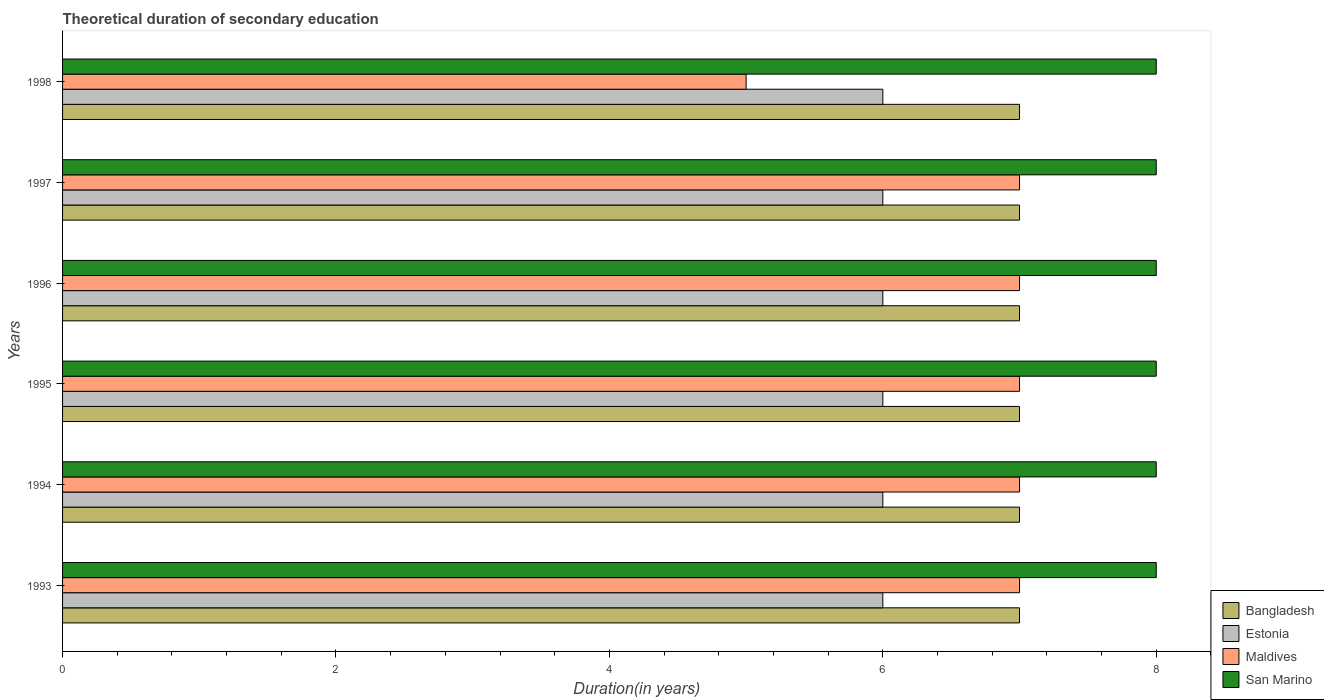Are the number of bars per tick equal to the number of legend labels?
Offer a terse response. Yes. Are the number of bars on each tick of the Y-axis equal?
Your answer should be compact. Yes. How many bars are there on the 6th tick from the top?
Your answer should be compact. 4. How many bars are there on the 2nd tick from the bottom?
Keep it short and to the point. 4. In how many cases, is the number of bars for a given year not equal to the number of legend labels?
Your answer should be compact. 0. What is the total theoretical duration of secondary education in Estonia in 1998?
Provide a short and direct response. 6. Across all years, what is the minimum total theoretical duration of secondary education in Maldives?
Offer a very short reply. 5. In which year was the total theoretical duration of secondary education in Maldives minimum?
Give a very brief answer. 1998. What is the total total theoretical duration of secondary education in Bangladesh in the graph?
Your response must be concise. 42. What is the difference between the total theoretical duration of secondary education in Maldives in 1994 and the total theoretical duration of secondary education in San Marino in 1996?
Ensure brevity in your answer.  -1. What is the average total theoretical duration of secondary education in Bangladesh per year?
Make the answer very short. 7. In the year 1995, what is the difference between the total theoretical duration of secondary education in Maldives and total theoretical duration of secondary education in San Marino?
Provide a short and direct response. -1. In how many years, is the total theoretical duration of secondary education in Maldives greater than 4.8 years?
Offer a very short reply. 6. What is the ratio of the total theoretical duration of secondary education in San Marino in 1993 to that in 1998?
Your answer should be compact. 1. Is the total theoretical duration of secondary education in Bangladesh in 1996 less than that in 1998?
Keep it short and to the point. No. What is the difference between the highest and the second highest total theoretical duration of secondary education in Maldives?
Your answer should be very brief. 0. What is the difference between the highest and the lowest total theoretical duration of secondary education in San Marino?
Offer a very short reply. 0. Is the sum of the total theoretical duration of secondary education in Maldives in 1995 and 1996 greater than the maximum total theoretical duration of secondary education in Bangladesh across all years?
Your answer should be very brief. Yes. What does the 4th bar from the top in 1998 represents?
Make the answer very short. Bangladesh. What does the 4th bar from the bottom in 1997 represents?
Your answer should be very brief. San Marino. Is it the case that in every year, the sum of the total theoretical duration of secondary education in Maldives and total theoretical duration of secondary education in San Marino is greater than the total theoretical duration of secondary education in Estonia?
Provide a short and direct response. Yes. How many years are there in the graph?
Provide a succinct answer. 6. What is the difference between two consecutive major ticks on the X-axis?
Your answer should be very brief. 2. Does the graph contain any zero values?
Offer a very short reply. No. Does the graph contain grids?
Your response must be concise. No. How many legend labels are there?
Offer a terse response. 4. What is the title of the graph?
Offer a very short reply. Theoretical duration of secondary education. Does "Indonesia" appear as one of the legend labels in the graph?
Make the answer very short. No. What is the label or title of the X-axis?
Make the answer very short. Duration(in years). What is the Duration(in years) in Bangladesh in 1993?
Ensure brevity in your answer.  7. What is the Duration(in years) of San Marino in 1993?
Provide a succinct answer. 8. What is the Duration(in years) in San Marino in 1994?
Provide a short and direct response. 8. What is the Duration(in years) in Estonia in 1995?
Your response must be concise. 6. What is the Duration(in years) of Maldives in 1995?
Provide a short and direct response. 7. What is the Duration(in years) of San Marino in 1995?
Provide a short and direct response. 8. What is the Duration(in years) of Bangladesh in 1996?
Keep it short and to the point. 7. What is the Duration(in years) of Maldives in 1996?
Your response must be concise. 7. What is the Duration(in years) of Bangladesh in 1997?
Keep it short and to the point. 7. What is the Duration(in years) of Maldives in 1997?
Ensure brevity in your answer.  7. What is the Duration(in years) of San Marino in 1997?
Provide a succinct answer. 8. What is the Duration(in years) in Maldives in 1998?
Offer a very short reply. 5. Across all years, what is the maximum Duration(in years) of Bangladesh?
Provide a short and direct response. 7. Across all years, what is the maximum Duration(in years) of Estonia?
Provide a succinct answer. 6. Across all years, what is the maximum Duration(in years) of San Marino?
Your answer should be compact. 8. Across all years, what is the minimum Duration(in years) in Estonia?
Ensure brevity in your answer.  6. Across all years, what is the minimum Duration(in years) of San Marino?
Keep it short and to the point. 8. What is the total Duration(in years) of San Marino in the graph?
Your response must be concise. 48. What is the difference between the Duration(in years) of Maldives in 1993 and that in 1994?
Ensure brevity in your answer.  0. What is the difference between the Duration(in years) of Estonia in 1993 and that in 1995?
Provide a short and direct response. 0. What is the difference between the Duration(in years) of San Marino in 1993 and that in 1995?
Offer a terse response. 0. What is the difference between the Duration(in years) in Bangladesh in 1993 and that in 1996?
Provide a succinct answer. 0. What is the difference between the Duration(in years) of Estonia in 1993 and that in 1996?
Keep it short and to the point. 0. What is the difference between the Duration(in years) of Maldives in 1993 and that in 1996?
Your answer should be very brief. 0. What is the difference between the Duration(in years) of Bangladesh in 1993 and that in 1997?
Your response must be concise. 0. What is the difference between the Duration(in years) in Maldives in 1993 and that in 1997?
Keep it short and to the point. 0. What is the difference between the Duration(in years) in Bangladesh in 1993 and that in 1998?
Provide a succinct answer. 0. What is the difference between the Duration(in years) of Estonia in 1993 and that in 1998?
Your answer should be compact. 0. What is the difference between the Duration(in years) in San Marino in 1993 and that in 1998?
Make the answer very short. 0. What is the difference between the Duration(in years) of Bangladesh in 1994 and that in 1996?
Give a very brief answer. 0. What is the difference between the Duration(in years) in San Marino in 1994 and that in 1996?
Your response must be concise. 0. What is the difference between the Duration(in years) of Bangladesh in 1994 and that in 1997?
Make the answer very short. 0. What is the difference between the Duration(in years) in Estonia in 1994 and that in 1997?
Your answer should be compact. 0. What is the difference between the Duration(in years) in Estonia in 1994 and that in 1998?
Keep it short and to the point. 0. What is the difference between the Duration(in years) of Maldives in 1994 and that in 1998?
Offer a very short reply. 2. What is the difference between the Duration(in years) of Bangladesh in 1995 and that in 1996?
Keep it short and to the point. 0. What is the difference between the Duration(in years) of Maldives in 1995 and that in 1996?
Your answer should be compact. 0. What is the difference between the Duration(in years) in Estonia in 1995 and that in 1997?
Provide a succinct answer. 0. What is the difference between the Duration(in years) in Maldives in 1995 and that in 1997?
Your answer should be very brief. 0. What is the difference between the Duration(in years) of Bangladesh in 1996 and that in 1997?
Ensure brevity in your answer.  0. What is the difference between the Duration(in years) in Estonia in 1996 and that in 1997?
Provide a short and direct response. 0. What is the difference between the Duration(in years) of San Marino in 1996 and that in 1998?
Provide a short and direct response. 0. What is the difference between the Duration(in years) in Bangladesh in 1997 and that in 1998?
Make the answer very short. 0. What is the difference between the Duration(in years) of Estonia in 1997 and that in 1998?
Provide a succinct answer. 0. What is the difference between the Duration(in years) of Maldives in 1997 and that in 1998?
Offer a very short reply. 2. What is the difference between the Duration(in years) in Bangladesh in 1993 and the Duration(in years) in Estonia in 1994?
Ensure brevity in your answer.  1. What is the difference between the Duration(in years) of Bangladesh in 1993 and the Duration(in years) of Maldives in 1994?
Offer a very short reply. 0. What is the difference between the Duration(in years) in Estonia in 1993 and the Duration(in years) in Maldives in 1994?
Give a very brief answer. -1. What is the difference between the Duration(in years) of Estonia in 1993 and the Duration(in years) of San Marino in 1994?
Keep it short and to the point. -2. What is the difference between the Duration(in years) in Estonia in 1993 and the Duration(in years) in Maldives in 1995?
Ensure brevity in your answer.  -1. What is the difference between the Duration(in years) in Bangladesh in 1993 and the Duration(in years) in Estonia in 1996?
Provide a succinct answer. 1. What is the difference between the Duration(in years) of Estonia in 1993 and the Duration(in years) of Maldives in 1996?
Provide a succinct answer. -1. What is the difference between the Duration(in years) of Estonia in 1993 and the Duration(in years) of San Marino in 1996?
Offer a terse response. -2. What is the difference between the Duration(in years) of Bangladesh in 1993 and the Duration(in years) of Estonia in 1997?
Provide a succinct answer. 1. What is the difference between the Duration(in years) in Estonia in 1993 and the Duration(in years) in San Marino in 1997?
Provide a short and direct response. -2. What is the difference between the Duration(in years) of Bangladesh in 1993 and the Duration(in years) of Maldives in 1998?
Your response must be concise. 2. What is the difference between the Duration(in years) in Bangladesh in 1993 and the Duration(in years) in San Marino in 1998?
Offer a very short reply. -1. What is the difference between the Duration(in years) of Maldives in 1993 and the Duration(in years) of San Marino in 1998?
Offer a terse response. -1. What is the difference between the Duration(in years) in Bangladesh in 1994 and the Duration(in years) in Estonia in 1995?
Offer a terse response. 1. What is the difference between the Duration(in years) of Bangladesh in 1994 and the Duration(in years) of Maldives in 1995?
Make the answer very short. 0. What is the difference between the Duration(in years) of Bangladesh in 1994 and the Duration(in years) of San Marino in 1995?
Give a very brief answer. -1. What is the difference between the Duration(in years) in Estonia in 1994 and the Duration(in years) in Maldives in 1995?
Ensure brevity in your answer.  -1. What is the difference between the Duration(in years) in Estonia in 1994 and the Duration(in years) in San Marino in 1995?
Give a very brief answer. -2. What is the difference between the Duration(in years) of Maldives in 1994 and the Duration(in years) of San Marino in 1995?
Your answer should be very brief. -1. What is the difference between the Duration(in years) in Bangladesh in 1994 and the Duration(in years) in San Marino in 1996?
Give a very brief answer. -1. What is the difference between the Duration(in years) of Estonia in 1994 and the Duration(in years) of San Marino in 1996?
Your answer should be compact. -2. What is the difference between the Duration(in years) in Maldives in 1994 and the Duration(in years) in San Marino in 1996?
Offer a terse response. -1. What is the difference between the Duration(in years) of Bangladesh in 1994 and the Duration(in years) of Maldives in 1997?
Provide a short and direct response. 0. What is the difference between the Duration(in years) in Bangladesh in 1994 and the Duration(in years) in San Marino in 1997?
Keep it short and to the point. -1. What is the difference between the Duration(in years) in Estonia in 1994 and the Duration(in years) in Maldives in 1997?
Make the answer very short. -1. What is the difference between the Duration(in years) in Bangladesh in 1994 and the Duration(in years) in Estonia in 1998?
Keep it short and to the point. 1. What is the difference between the Duration(in years) in Estonia in 1994 and the Duration(in years) in San Marino in 1998?
Your response must be concise. -2. What is the difference between the Duration(in years) in Maldives in 1994 and the Duration(in years) in San Marino in 1998?
Provide a short and direct response. -1. What is the difference between the Duration(in years) of Bangladesh in 1995 and the Duration(in years) of Estonia in 1996?
Keep it short and to the point. 1. What is the difference between the Duration(in years) of Bangladesh in 1995 and the Duration(in years) of Maldives in 1996?
Make the answer very short. 0. What is the difference between the Duration(in years) of Estonia in 1995 and the Duration(in years) of Maldives in 1996?
Make the answer very short. -1. What is the difference between the Duration(in years) in Bangladesh in 1995 and the Duration(in years) in Maldives in 1997?
Your response must be concise. 0. What is the difference between the Duration(in years) in Estonia in 1995 and the Duration(in years) in Maldives in 1997?
Provide a short and direct response. -1. What is the difference between the Duration(in years) of Bangladesh in 1995 and the Duration(in years) of Estonia in 1998?
Ensure brevity in your answer.  1. What is the difference between the Duration(in years) in Bangladesh in 1995 and the Duration(in years) in Maldives in 1998?
Provide a succinct answer. 2. What is the difference between the Duration(in years) of Bangladesh in 1995 and the Duration(in years) of San Marino in 1998?
Make the answer very short. -1. What is the difference between the Duration(in years) of Estonia in 1995 and the Duration(in years) of Maldives in 1998?
Make the answer very short. 1. What is the difference between the Duration(in years) of Estonia in 1995 and the Duration(in years) of San Marino in 1998?
Ensure brevity in your answer.  -2. What is the difference between the Duration(in years) in Maldives in 1995 and the Duration(in years) in San Marino in 1998?
Give a very brief answer. -1. What is the difference between the Duration(in years) of Bangladesh in 1996 and the Duration(in years) of Maldives in 1997?
Provide a short and direct response. 0. What is the difference between the Duration(in years) in Bangladesh in 1996 and the Duration(in years) in San Marino in 1997?
Ensure brevity in your answer.  -1. What is the difference between the Duration(in years) in Estonia in 1996 and the Duration(in years) in San Marino in 1997?
Ensure brevity in your answer.  -2. What is the difference between the Duration(in years) of Maldives in 1996 and the Duration(in years) of San Marino in 1997?
Give a very brief answer. -1. What is the difference between the Duration(in years) of Bangladesh in 1996 and the Duration(in years) of San Marino in 1998?
Give a very brief answer. -1. What is the difference between the Duration(in years) of Estonia in 1996 and the Duration(in years) of Maldives in 1998?
Give a very brief answer. 1. What is the difference between the Duration(in years) in Bangladesh in 1997 and the Duration(in years) in Estonia in 1998?
Your answer should be compact. 1. What is the difference between the Duration(in years) of Bangladesh in 1997 and the Duration(in years) of San Marino in 1998?
Give a very brief answer. -1. What is the difference between the Duration(in years) in Maldives in 1997 and the Duration(in years) in San Marino in 1998?
Keep it short and to the point. -1. What is the average Duration(in years) in San Marino per year?
Your response must be concise. 8. In the year 1993, what is the difference between the Duration(in years) in Bangladesh and Duration(in years) in Estonia?
Make the answer very short. 1. In the year 1993, what is the difference between the Duration(in years) of Bangladesh and Duration(in years) of Maldives?
Your response must be concise. 0. In the year 1993, what is the difference between the Duration(in years) of Bangladesh and Duration(in years) of San Marino?
Ensure brevity in your answer.  -1. In the year 1993, what is the difference between the Duration(in years) of Estonia and Duration(in years) of San Marino?
Give a very brief answer. -2. In the year 1993, what is the difference between the Duration(in years) of Maldives and Duration(in years) of San Marino?
Your answer should be very brief. -1. In the year 1994, what is the difference between the Duration(in years) in Bangladesh and Duration(in years) in Estonia?
Make the answer very short. 1. In the year 1994, what is the difference between the Duration(in years) in Bangladesh and Duration(in years) in San Marino?
Provide a short and direct response. -1. In the year 1994, what is the difference between the Duration(in years) in Maldives and Duration(in years) in San Marino?
Provide a short and direct response. -1. In the year 1995, what is the difference between the Duration(in years) of Bangladesh and Duration(in years) of San Marino?
Your answer should be very brief. -1. In the year 1995, what is the difference between the Duration(in years) of Maldives and Duration(in years) of San Marino?
Keep it short and to the point. -1. In the year 1996, what is the difference between the Duration(in years) in Bangladesh and Duration(in years) in Estonia?
Ensure brevity in your answer.  1. In the year 1996, what is the difference between the Duration(in years) in Bangladesh and Duration(in years) in San Marino?
Provide a short and direct response. -1. In the year 1996, what is the difference between the Duration(in years) in Estonia and Duration(in years) in Maldives?
Offer a terse response. -1. In the year 1996, what is the difference between the Duration(in years) in Estonia and Duration(in years) in San Marino?
Provide a succinct answer. -2. In the year 1996, what is the difference between the Duration(in years) in Maldives and Duration(in years) in San Marino?
Provide a succinct answer. -1. In the year 1997, what is the difference between the Duration(in years) in Bangladesh and Duration(in years) in Maldives?
Your answer should be very brief. 0. In the year 1997, what is the difference between the Duration(in years) in Estonia and Duration(in years) in San Marino?
Keep it short and to the point. -2. In the year 1997, what is the difference between the Duration(in years) of Maldives and Duration(in years) of San Marino?
Your answer should be very brief. -1. In the year 1998, what is the difference between the Duration(in years) of Bangladesh and Duration(in years) of Estonia?
Make the answer very short. 1. In the year 1998, what is the difference between the Duration(in years) in Bangladesh and Duration(in years) in Maldives?
Offer a terse response. 2. In the year 1998, what is the difference between the Duration(in years) in Estonia and Duration(in years) in Maldives?
Offer a very short reply. 1. In the year 1998, what is the difference between the Duration(in years) of Maldives and Duration(in years) of San Marino?
Provide a short and direct response. -3. What is the ratio of the Duration(in years) in Bangladesh in 1993 to that in 1995?
Give a very brief answer. 1. What is the ratio of the Duration(in years) in Maldives in 1993 to that in 1995?
Provide a short and direct response. 1. What is the ratio of the Duration(in years) of San Marino in 1993 to that in 1995?
Offer a very short reply. 1. What is the ratio of the Duration(in years) in Bangladesh in 1993 to that in 1996?
Ensure brevity in your answer.  1. What is the ratio of the Duration(in years) of Estonia in 1993 to that in 1996?
Give a very brief answer. 1. What is the ratio of the Duration(in years) of San Marino in 1993 to that in 1996?
Offer a very short reply. 1. What is the ratio of the Duration(in years) in Bangladesh in 1993 to that in 1997?
Provide a short and direct response. 1. What is the ratio of the Duration(in years) of Estonia in 1993 to that in 1997?
Ensure brevity in your answer.  1. What is the ratio of the Duration(in years) of San Marino in 1993 to that in 1997?
Give a very brief answer. 1. What is the ratio of the Duration(in years) in Bangladesh in 1993 to that in 1998?
Provide a short and direct response. 1. What is the ratio of the Duration(in years) in San Marino in 1993 to that in 1998?
Give a very brief answer. 1. What is the ratio of the Duration(in years) in Bangladesh in 1994 to that in 1995?
Offer a terse response. 1. What is the ratio of the Duration(in years) in San Marino in 1994 to that in 1995?
Offer a very short reply. 1. What is the ratio of the Duration(in years) in Bangladesh in 1994 to that in 1996?
Ensure brevity in your answer.  1. What is the ratio of the Duration(in years) in Estonia in 1994 to that in 1996?
Make the answer very short. 1. What is the ratio of the Duration(in years) in San Marino in 1994 to that in 1996?
Your answer should be compact. 1. What is the ratio of the Duration(in years) in San Marino in 1994 to that in 1997?
Your answer should be very brief. 1. What is the ratio of the Duration(in years) in Estonia in 1994 to that in 1998?
Ensure brevity in your answer.  1. What is the ratio of the Duration(in years) in San Marino in 1994 to that in 1998?
Provide a short and direct response. 1. What is the ratio of the Duration(in years) of Bangladesh in 1995 to that in 1996?
Ensure brevity in your answer.  1. What is the ratio of the Duration(in years) in Estonia in 1995 to that in 1996?
Provide a short and direct response. 1. What is the ratio of the Duration(in years) in Maldives in 1995 to that in 1996?
Provide a succinct answer. 1. What is the ratio of the Duration(in years) of San Marino in 1995 to that in 1996?
Provide a succinct answer. 1. What is the ratio of the Duration(in years) of Maldives in 1995 to that in 1997?
Make the answer very short. 1. What is the ratio of the Duration(in years) in San Marino in 1995 to that in 1997?
Offer a very short reply. 1. What is the ratio of the Duration(in years) of Bangladesh in 1995 to that in 1998?
Offer a very short reply. 1. What is the ratio of the Duration(in years) in Estonia in 1995 to that in 1998?
Your answer should be compact. 1. What is the ratio of the Duration(in years) of San Marino in 1995 to that in 1998?
Offer a terse response. 1. What is the ratio of the Duration(in years) in Bangladesh in 1996 to that in 1997?
Your response must be concise. 1. What is the ratio of the Duration(in years) of Maldives in 1996 to that in 1997?
Keep it short and to the point. 1. What is the ratio of the Duration(in years) in Maldives in 1996 to that in 1998?
Provide a short and direct response. 1.4. What is the ratio of the Duration(in years) of San Marino in 1996 to that in 1998?
Ensure brevity in your answer.  1. What is the ratio of the Duration(in years) of Estonia in 1997 to that in 1998?
Give a very brief answer. 1. What is the ratio of the Duration(in years) of San Marino in 1997 to that in 1998?
Give a very brief answer. 1. What is the difference between the highest and the second highest Duration(in years) of Bangladesh?
Provide a succinct answer. 0. What is the difference between the highest and the second highest Duration(in years) of Estonia?
Offer a very short reply. 0. What is the difference between the highest and the second highest Duration(in years) in San Marino?
Offer a very short reply. 0. What is the difference between the highest and the lowest Duration(in years) of Maldives?
Offer a terse response. 2. 